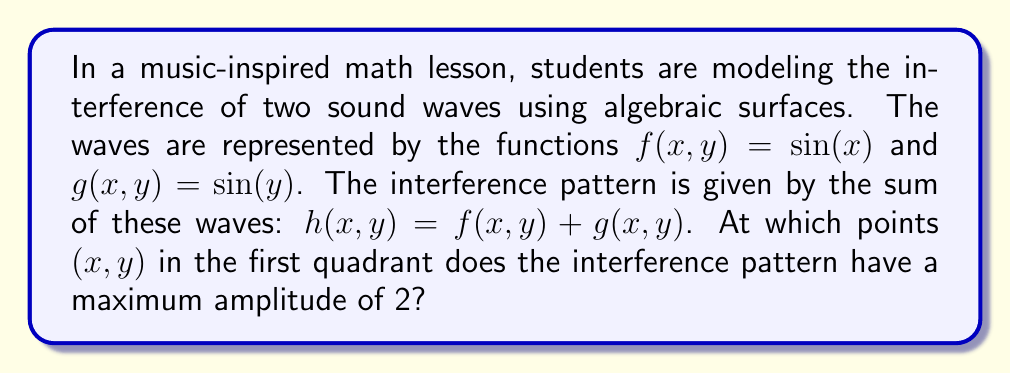Show me your answer to this math problem. To solve this problem, we'll follow these steps:

1) The interference pattern is given by:
   $h(x,y) = f(x,y) + g(x,y) = \sin(x) + \sin(y)$

2) We're looking for maximum amplitude, which occurs when $h(x,y) = 2$. So we need to solve:
   $\sin(x) + \sin(y) = 2$

3) Recall that $\sin$ has a maximum value of 1. For the sum to equal 2, both $\sin(x)$ and $\sin(y)$ must be at their maximum simultaneously.

4) $\sin(x) = 1$ when $x = \frac{\pi}{2} + 2\pi n$, where $n$ is any integer.
   $\sin(y) = 1$ when $y = \frac{\pi}{2} + 2\pi m$, where $m$ is any integer.

5) In the first quadrant (where $x$ and $y$ are positive), the smallest values that satisfy these conditions are:
   $x = \frac{\pi}{2}$ and $y = \frac{\pi}{2}$

6) Therefore, the point of maximum amplitude in the first quadrant is $(\frac{\pi}{2}, \frac{\pi}{2})$.

7) We can verify:
   $h(\frac{\pi}{2}, \frac{\pi}{2}) = \sin(\frac{\pi}{2}) + \sin(\frac{\pi}{2}) = 1 + 1 = 2$
Answer: $(\frac{\pi}{2}, \frac{\pi}{2})$ 